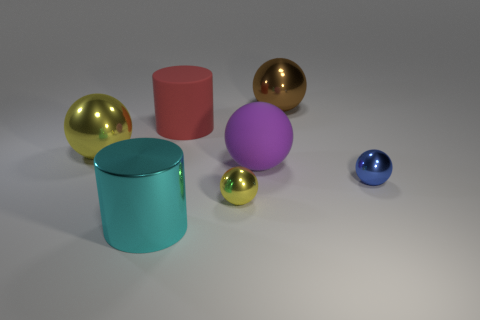Add 2 rubber spheres. How many objects exist? 9 Subtract all big spheres. How many spheres are left? 2 Subtract all red cylinders. How many cylinders are left? 1 Subtract 2 cylinders. How many cylinders are left? 0 Subtract 0 red spheres. How many objects are left? 7 Subtract all spheres. How many objects are left? 2 Subtract all brown cylinders. Subtract all gray spheres. How many cylinders are left? 2 Subtract all brown blocks. How many red cylinders are left? 1 Subtract all shiny things. Subtract all brown shiny spheres. How many objects are left? 1 Add 6 rubber spheres. How many rubber spheres are left? 7 